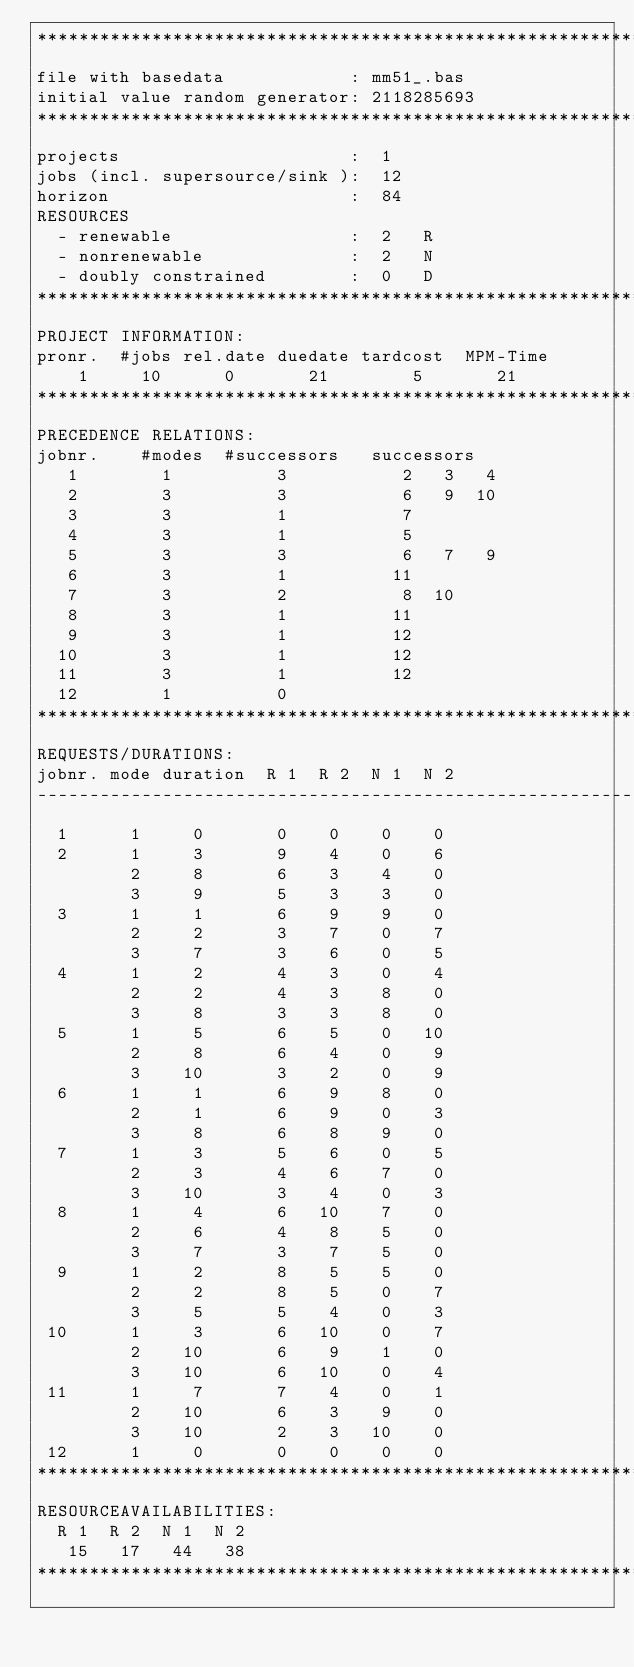<code> <loc_0><loc_0><loc_500><loc_500><_ObjectiveC_>************************************************************************
file with basedata            : mm51_.bas
initial value random generator: 2118285693
************************************************************************
projects                      :  1
jobs (incl. supersource/sink ):  12
horizon                       :  84
RESOURCES
  - renewable                 :  2   R
  - nonrenewable              :  2   N
  - doubly constrained        :  0   D
************************************************************************
PROJECT INFORMATION:
pronr.  #jobs rel.date duedate tardcost  MPM-Time
    1     10      0       21        5       21
************************************************************************
PRECEDENCE RELATIONS:
jobnr.    #modes  #successors   successors
   1        1          3           2   3   4
   2        3          3           6   9  10
   3        3          1           7
   4        3          1           5
   5        3          3           6   7   9
   6        3          1          11
   7        3          2           8  10
   8        3          1          11
   9        3          1          12
  10        3          1          12
  11        3          1          12
  12        1          0        
************************************************************************
REQUESTS/DURATIONS:
jobnr. mode duration  R 1  R 2  N 1  N 2
------------------------------------------------------------------------
  1      1     0       0    0    0    0
  2      1     3       9    4    0    6
         2     8       6    3    4    0
         3     9       5    3    3    0
  3      1     1       6    9    9    0
         2     2       3    7    0    7
         3     7       3    6    0    5
  4      1     2       4    3    0    4
         2     2       4    3    8    0
         3     8       3    3    8    0
  5      1     5       6    5    0   10
         2     8       6    4    0    9
         3    10       3    2    0    9
  6      1     1       6    9    8    0
         2     1       6    9    0    3
         3     8       6    8    9    0
  7      1     3       5    6    0    5
         2     3       4    6    7    0
         3    10       3    4    0    3
  8      1     4       6   10    7    0
         2     6       4    8    5    0
         3     7       3    7    5    0
  9      1     2       8    5    5    0
         2     2       8    5    0    7
         3     5       5    4    0    3
 10      1     3       6   10    0    7
         2    10       6    9    1    0
         3    10       6   10    0    4
 11      1     7       7    4    0    1
         2    10       6    3    9    0
         3    10       2    3   10    0
 12      1     0       0    0    0    0
************************************************************************
RESOURCEAVAILABILITIES:
  R 1  R 2  N 1  N 2
   15   17   44   38
************************************************************************
</code> 